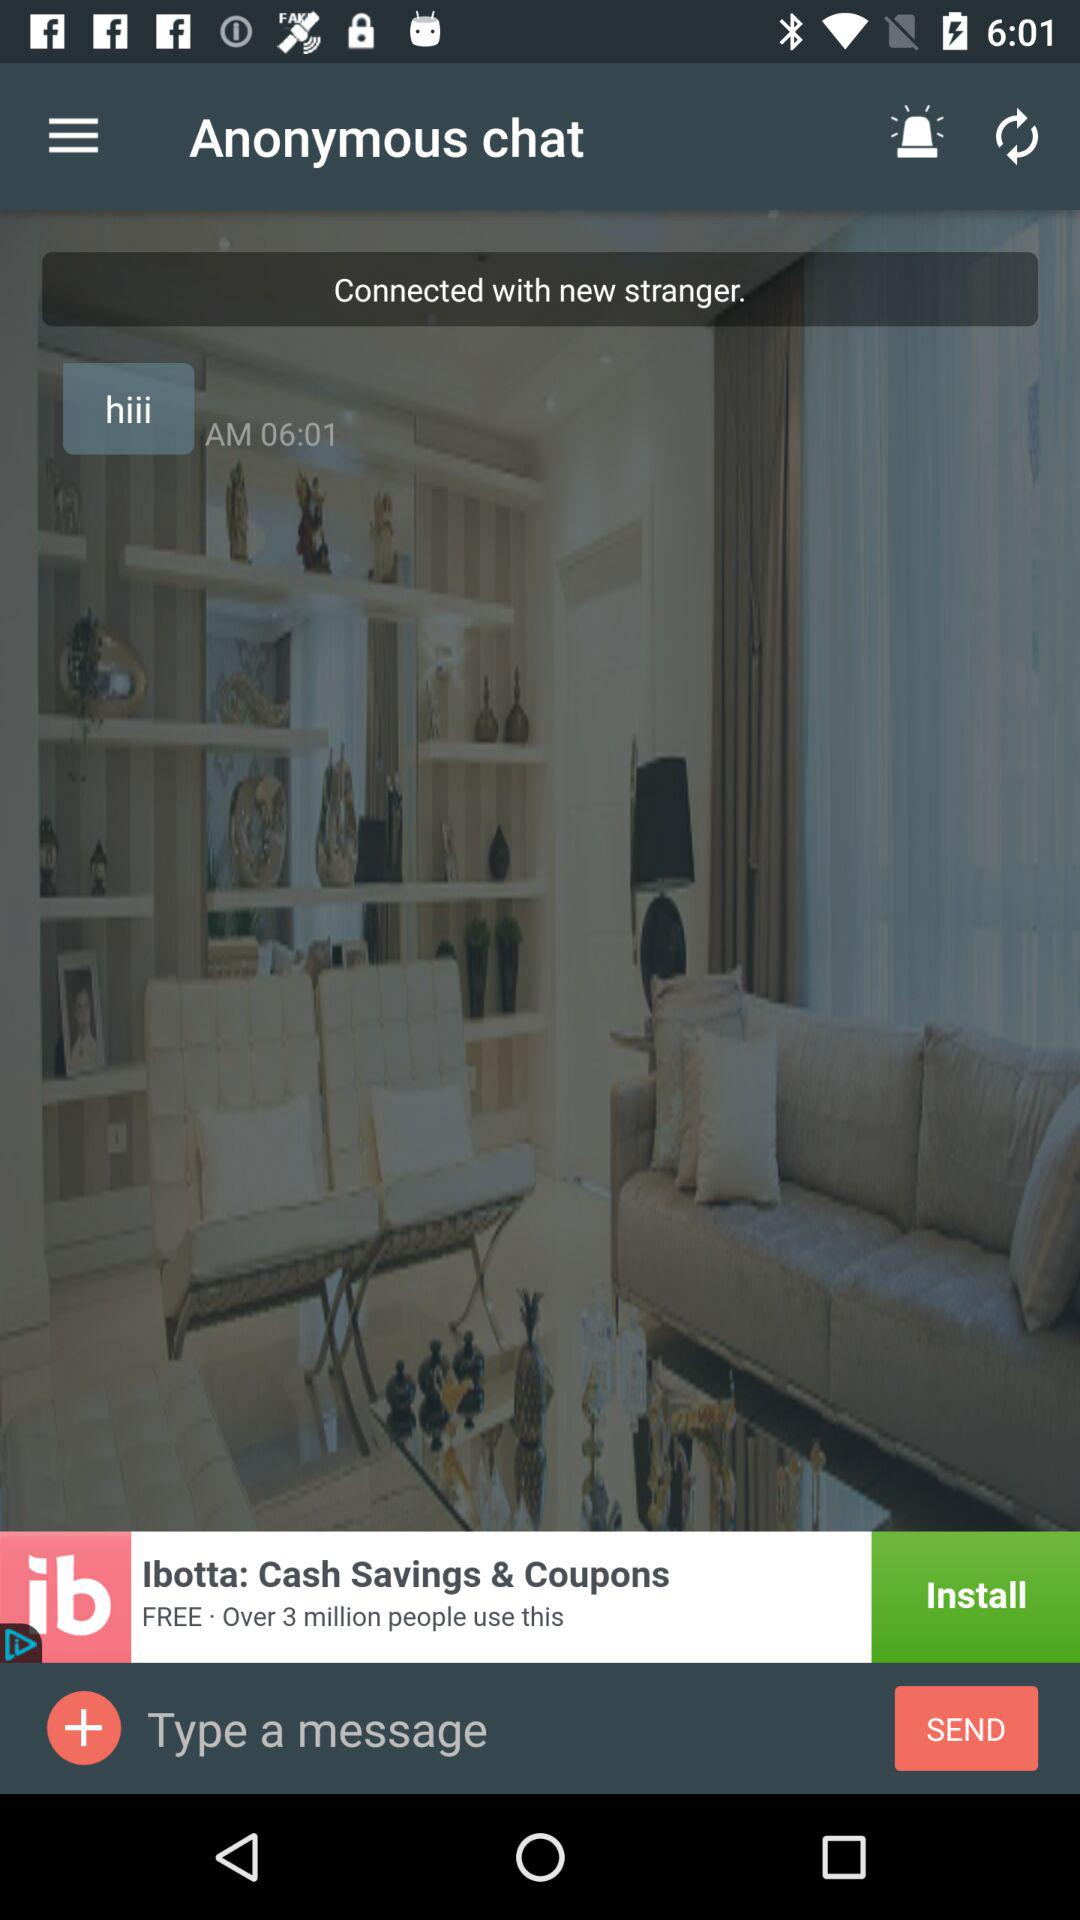How can we share "Anonymous chat" messages?
When the provided information is insufficient, respond with <no answer>. <no answer> 